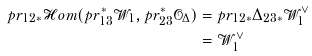Convert formula to latex. <formula><loc_0><loc_0><loc_500><loc_500>p r _ { 1 2 * } \mathcal { H } o m ( p r _ { 1 3 } ^ { * } \mathcal { W } _ { 1 } , p r _ { 2 3 } ^ { * } \mathcal { O } _ { \Delta } ) & = p r _ { 1 2 * } \Delta _ { 2 3 * } \mathcal { W } _ { 1 } ^ { \vee } \\ & = \mathcal { W } _ { 1 } ^ { \vee }</formula> 